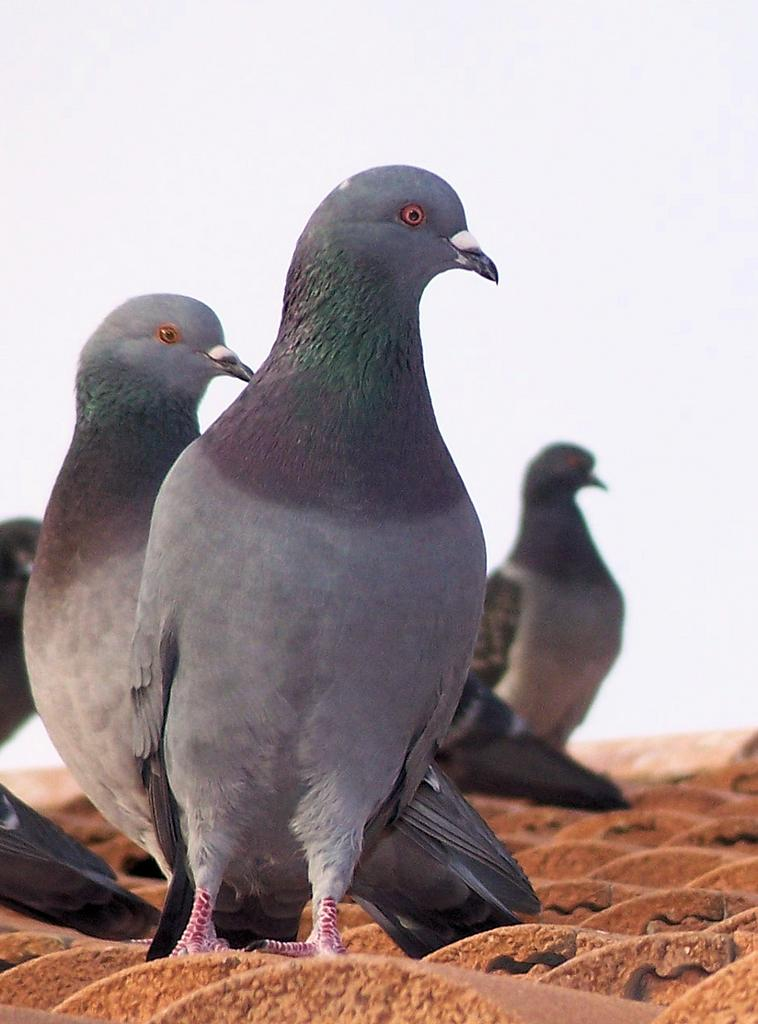What type of animals can be seen on the surface in the image? There are birds on the surface in the image. What color is the background of the image? The background of the image is white. What committee is responsible for the drain in the image? There is no drain present in the image, and therefore no committee is responsible for it. 